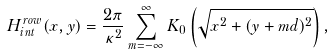<formula> <loc_0><loc_0><loc_500><loc_500>H _ { i n t } ^ { r o w } ( x , y ) = \frac { 2 \pi } { \kappa ^ { 2 } } \sum _ { m = - \infty } ^ { \infty } K _ { 0 } \left ( \sqrt { x ^ { 2 } + ( y + m d ) ^ { 2 } } \right ) ,</formula> 